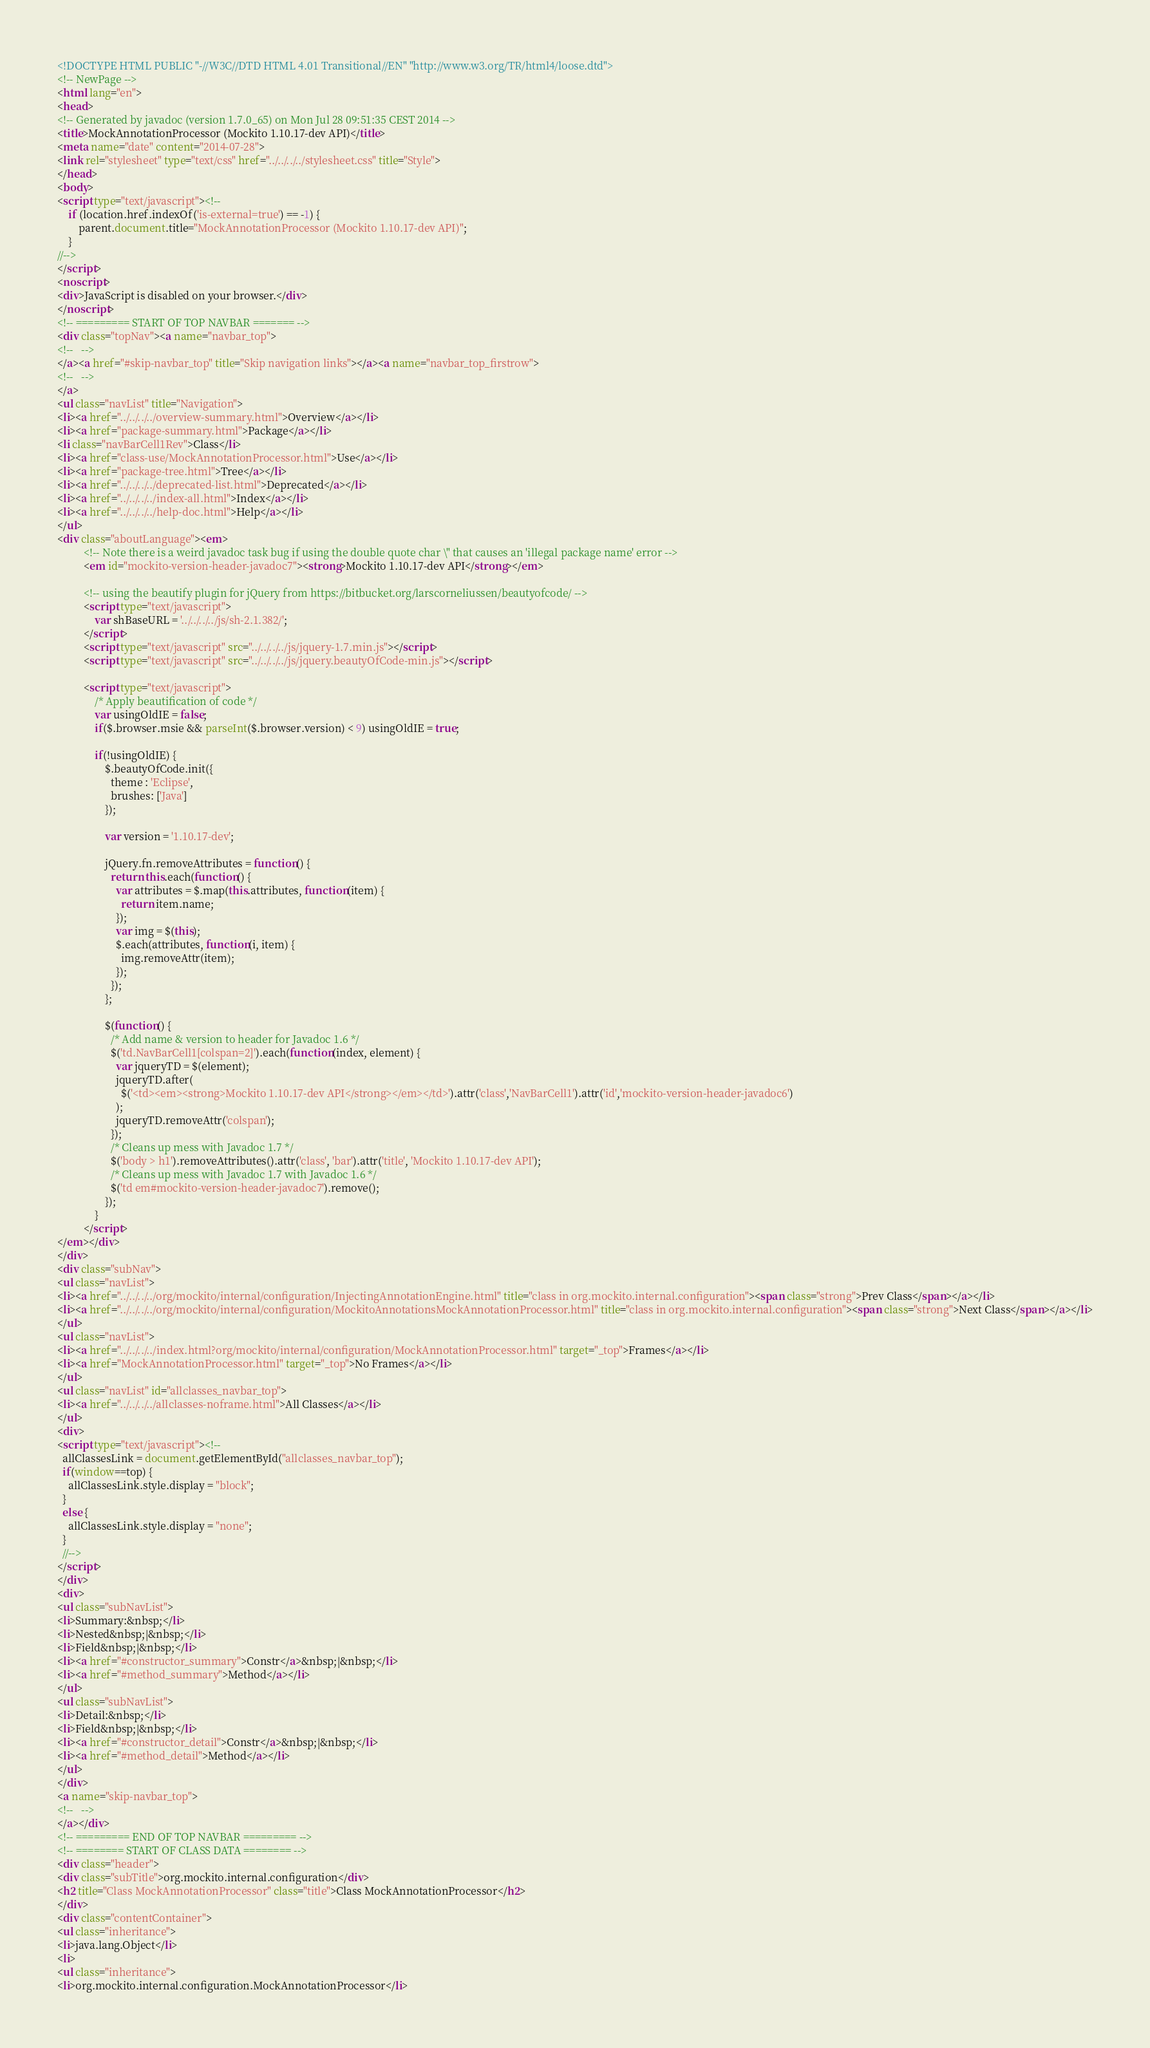Convert code to text. <code><loc_0><loc_0><loc_500><loc_500><_HTML_><!DOCTYPE HTML PUBLIC "-//W3C//DTD HTML 4.01 Transitional//EN" "http://www.w3.org/TR/html4/loose.dtd">
<!-- NewPage -->
<html lang="en">
<head>
<!-- Generated by javadoc (version 1.7.0_65) on Mon Jul 28 09:51:35 CEST 2014 -->
<title>MockAnnotationProcessor (Mockito 1.10.17-dev API)</title>
<meta name="date" content="2014-07-28">
<link rel="stylesheet" type="text/css" href="../../../../stylesheet.css" title="Style">
</head>
<body>
<script type="text/javascript"><!--
    if (location.href.indexOf('is-external=true') == -1) {
        parent.document.title="MockAnnotationProcessor (Mockito 1.10.17-dev API)";
    }
//-->
</script>
<noscript>
<div>JavaScript is disabled on your browser.</div>
</noscript>
<!-- ========= START OF TOP NAVBAR ======= -->
<div class="topNav"><a name="navbar_top">
<!--   -->
</a><a href="#skip-navbar_top" title="Skip navigation links"></a><a name="navbar_top_firstrow">
<!--   -->
</a>
<ul class="navList" title="Navigation">
<li><a href="../../../../overview-summary.html">Overview</a></li>
<li><a href="package-summary.html">Package</a></li>
<li class="navBarCell1Rev">Class</li>
<li><a href="class-use/MockAnnotationProcessor.html">Use</a></li>
<li><a href="package-tree.html">Tree</a></li>
<li><a href="../../../../deprecated-list.html">Deprecated</a></li>
<li><a href="../../../../index-all.html">Index</a></li>
<li><a href="../../../../help-doc.html">Help</a></li>
</ul>
<div class="aboutLanguage"><em>
          <!-- Note there is a weird javadoc task bug if using the double quote char \" that causes an 'illegal package name' error -->
          <em id="mockito-version-header-javadoc7"><strong>Mockito 1.10.17-dev API</strong></em>

          <!-- using the beautify plugin for jQuery from https://bitbucket.org/larscorneliussen/beautyofcode/ -->
          <script type="text/javascript">
              var shBaseURL = '../../../../js/sh-2.1.382/';
          </script>
          <script type="text/javascript" src="../../../../js/jquery-1.7.min.js"></script>
          <script type="text/javascript" src="../../../../js/jquery.beautyOfCode-min.js"></script>

          <script type="text/javascript">
              /* Apply beautification of code */
              var usingOldIE = false;
              if($.browser.msie && parseInt($.browser.version) < 9) usingOldIE = true;

              if(!usingOldIE) {
                  $.beautyOfCode.init({
                    theme : 'Eclipse',
                    brushes: ['Java']
                  });

                  var version = '1.10.17-dev';

                  jQuery.fn.removeAttributes = function() {
                    return this.each(function() {
                      var attributes = $.map(this.attributes, function(item) {
                        return item.name;
                      });
                      var img = $(this);
                      $.each(attributes, function(i, item) {
                        img.removeAttr(item);
                      });
                    });
                  };

                  $(function() {
                    /* Add name & version to header for Javadoc 1.6 */
                    $('td.NavBarCell1[colspan=2]').each(function(index, element) {
                      var jqueryTD = $(element);
                      jqueryTD.after(
                        $('<td><em><strong>Mockito 1.10.17-dev API</strong></em></td>').attr('class','NavBarCell1').attr('id','mockito-version-header-javadoc6')
                      );
                      jqueryTD.removeAttr('colspan');
                    });
                    /* Cleans up mess with Javadoc 1.7 */
                    $('body > h1').removeAttributes().attr('class', 'bar').attr('title', 'Mockito 1.10.17-dev API');
                    /* Cleans up mess with Javadoc 1.7 with Javadoc 1.6 */
                    $('td em#mockito-version-header-javadoc7').remove();
                  });
              }
          </script>
</em></div>
</div>
<div class="subNav">
<ul class="navList">
<li><a href="../../../../org/mockito/internal/configuration/InjectingAnnotationEngine.html" title="class in org.mockito.internal.configuration"><span class="strong">Prev Class</span></a></li>
<li><a href="../../../../org/mockito/internal/configuration/MockitoAnnotationsMockAnnotationProcessor.html" title="class in org.mockito.internal.configuration"><span class="strong">Next Class</span></a></li>
</ul>
<ul class="navList">
<li><a href="../../../../index.html?org/mockito/internal/configuration/MockAnnotationProcessor.html" target="_top">Frames</a></li>
<li><a href="MockAnnotationProcessor.html" target="_top">No Frames</a></li>
</ul>
<ul class="navList" id="allclasses_navbar_top">
<li><a href="../../../../allclasses-noframe.html">All Classes</a></li>
</ul>
<div>
<script type="text/javascript"><!--
  allClassesLink = document.getElementById("allclasses_navbar_top");
  if(window==top) {
    allClassesLink.style.display = "block";
  }
  else {
    allClassesLink.style.display = "none";
  }
  //-->
</script>
</div>
<div>
<ul class="subNavList">
<li>Summary:&nbsp;</li>
<li>Nested&nbsp;|&nbsp;</li>
<li>Field&nbsp;|&nbsp;</li>
<li><a href="#constructor_summary">Constr</a>&nbsp;|&nbsp;</li>
<li><a href="#method_summary">Method</a></li>
</ul>
<ul class="subNavList">
<li>Detail:&nbsp;</li>
<li>Field&nbsp;|&nbsp;</li>
<li><a href="#constructor_detail">Constr</a>&nbsp;|&nbsp;</li>
<li><a href="#method_detail">Method</a></li>
</ul>
</div>
<a name="skip-navbar_top">
<!--   -->
</a></div>
<!-- ========= END OF TOP NAVBAR ========= -->
<!-- ======== START OF CLASS DATA ======== -->
<div class="header">
<div class="subTitle">org.mockito.internal.configuration</div>
<h2 title="Class MockAnnotationProcessor" class="title">Class MockAnnotationProcessor</h2>
</div>
<div class="contentContainer">
<ul class="inheritance">
<li>java.lang.Object</li>
<li>
<ul class="inheritance">
<li>org.mockito.internal.configuration.MockAnnotationProcessor</li></code> 